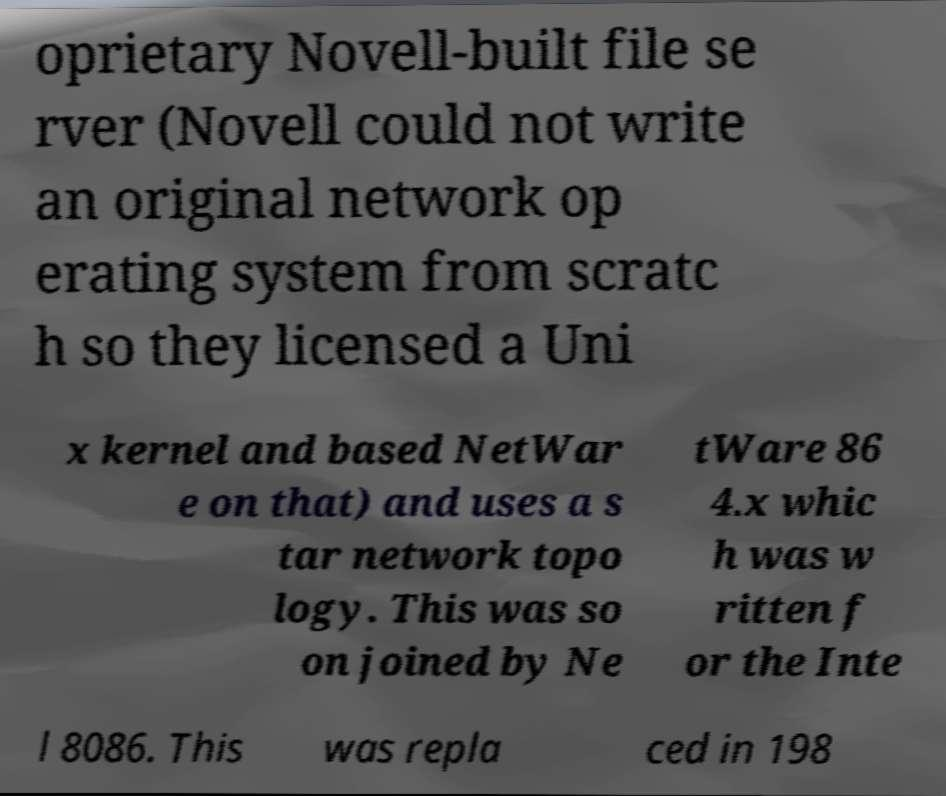Could you extract and type out the text from this image? oprietary Novell-built file se rver (Novell could not write an original network op erating system from scratc h so they licensed a Uni x kernel and based NetWar e on that) and uses a s tar network topo logy. This was so on joined by Ne tWare 86 4.x whic h was w ritten f or the Inte l 8086. This was repla ced in 198 